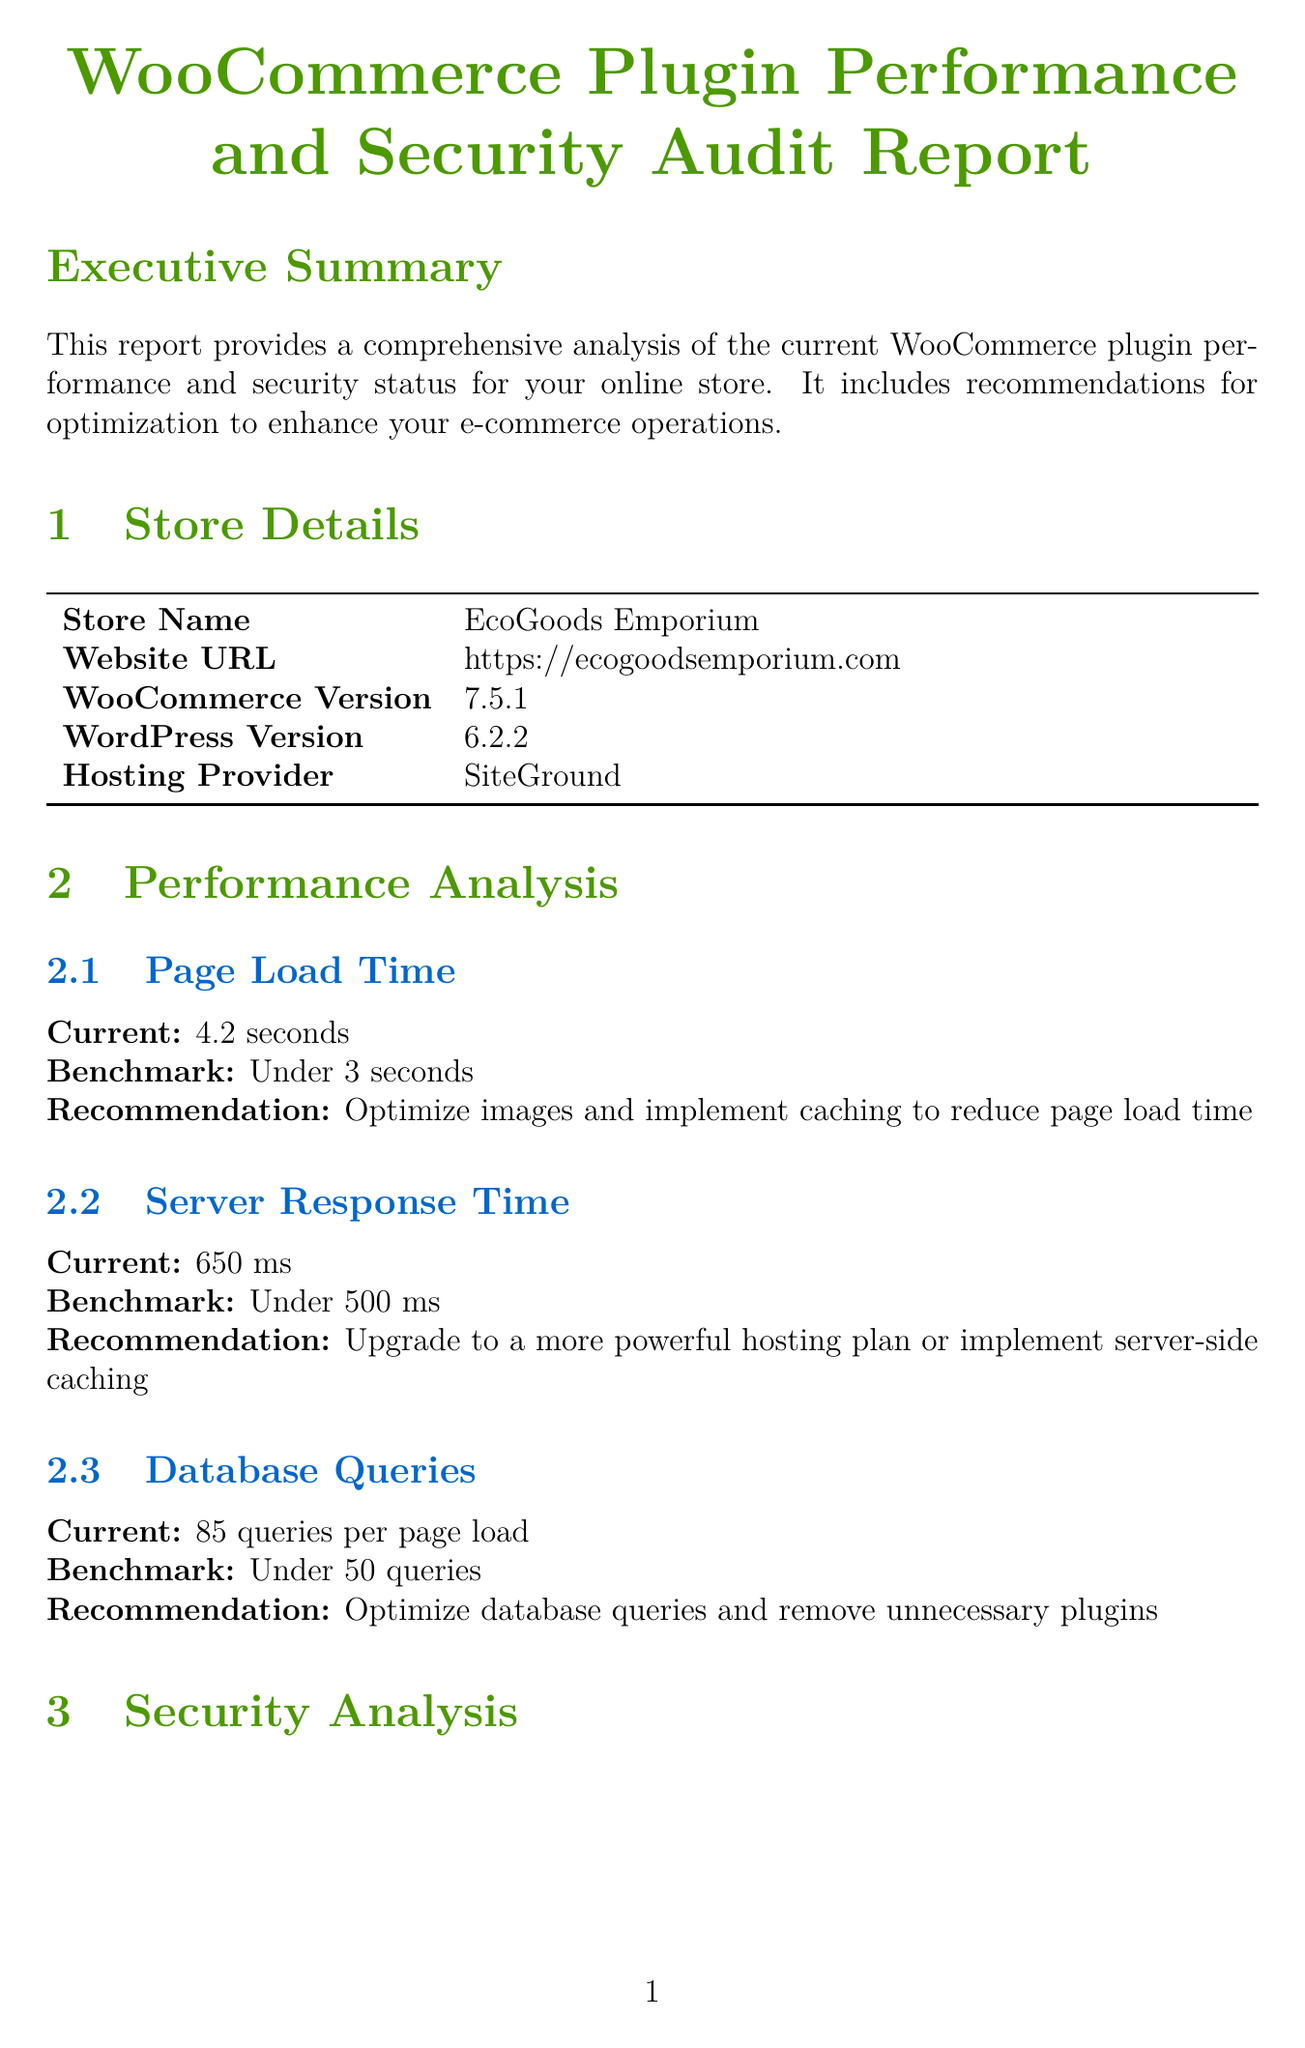What is the store name? The store name is listed in the store details section of the document.
Answer: EcoGoods Emporium What is the current WooCommerce version? The current WooCommerce version can be found in the store details section.
Answer: 7.5.1 What is the current page load time? The current page load time is specified in the performance analysis section.
Answer: 4.2 seconds How many outdated plugins are there? The number of outdated plugins is mentioned in the security analysis section.
Answer: 3 What is the recommendation for server response time? The recommendation for server response time can be found in the performance analysis section.
Answer: Upgrade to a more powerful hosting plan or implement server-side caching What is the status of the SSL certificate? The status of the SSL certificate is given in the security analysis section.
Answer: Valid What should be enabled for user roles and permissions? The recommendation regarding user roles and permissions is in the security analysis.
Answer: Two-factor authentication What is one of the performance optimization steps? The performance optimization steps are listed, and any of those can be an answer.
Answer: Implement a Content Delivery Network (CDN) like Cloudflare How often should audits be scheduled? The scheduling frequency for audits is mentioned in the next steps section.
Answer: Every 3 months 